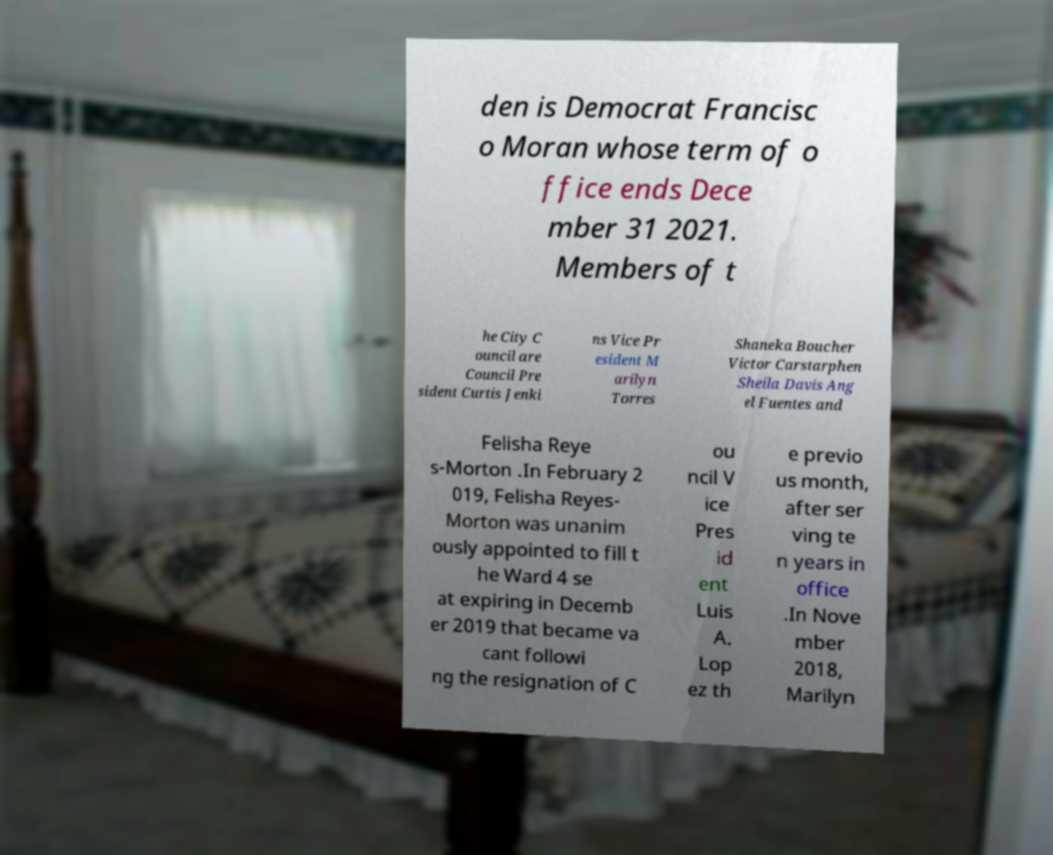What messages or text are displayed in this image? I need them in a readable, typed format. den is Democrat Francisc o Moran whose term of o ffice ends Dece mber 31 2021. Members of t he City C ouncil are Council Pre sident Curtis Jenki ns Vice Pr esident M arilyn Torres Shaneka Boucher Victor Carstarphen Sheila Davis Ang el Fuentes and Felisha Reye s-Morton .In February 2 019, Felisha Reyes- Morton was unanim ously appointed to fill t he Ward 4 se at expiring in Decemb er 2019 that became va cant followi ng the resignation of C ou ncil V ice Pres id ent Luis A. Lop ez th e previo us month, after ser ving te n years in office .In Nove mber 2018, Marilyn 